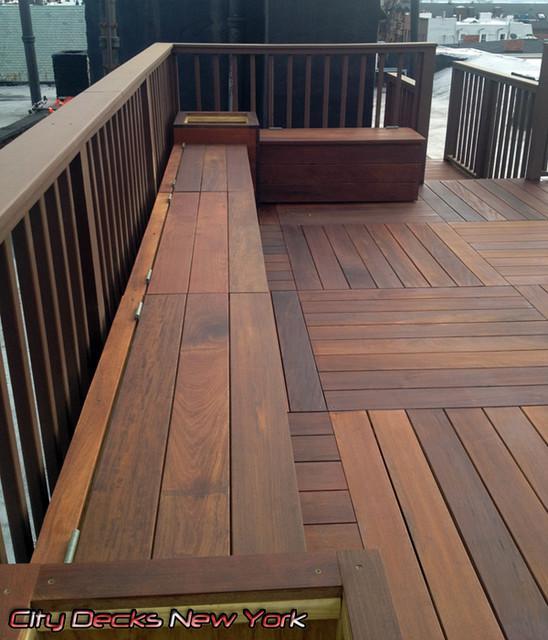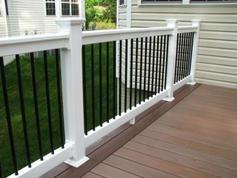The first image is the image on the left, the second image is the image on the right. Examine the images to the left and right. Is the description "One of the railings is black and white." accurate? Answer yes or no. Yes. The first image is the image on the left, the second image is the image on the right. Given the left and right images, does the statement "A wooden deck has bright white rails with black balusters." hold true? Answer yes or no. Yes. 